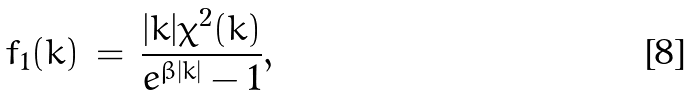<formula> <loc_0><loc_0><loc_500><loc_500>f _ { 1 } ( k ) \, = \, \frac { | k | \chi ^ { 2 } ( k ) } { e ^ { \beta | k | } - 1 } ,</formula> 